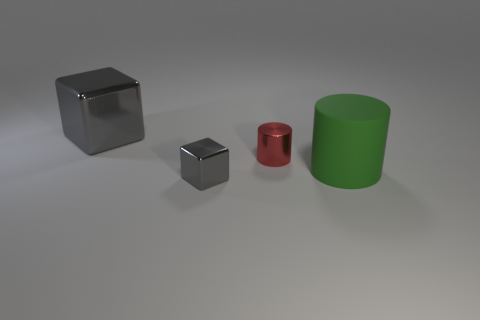Subtract all green cylinders. How many cylinders are left? 1 Add 4 brown matte cylinders. How many objects exist? 8 Add 3 big matte things. How many big matte things are left? 4 Add 4 red cylinders. How many red cylinders exist? 5 Subtract 0 green blocks. How many objects are left? 4 Subtract 2 cubes. How many cubes are left? 0 Subtract all gray cylinders. Subtract all purple balls. How many cylinders are left? 2 Subtract all green balls. How many red cylinders are left? 1 Subtract all large purple shiny objects. Subtract all green rubber things. How many objects are left? 3 